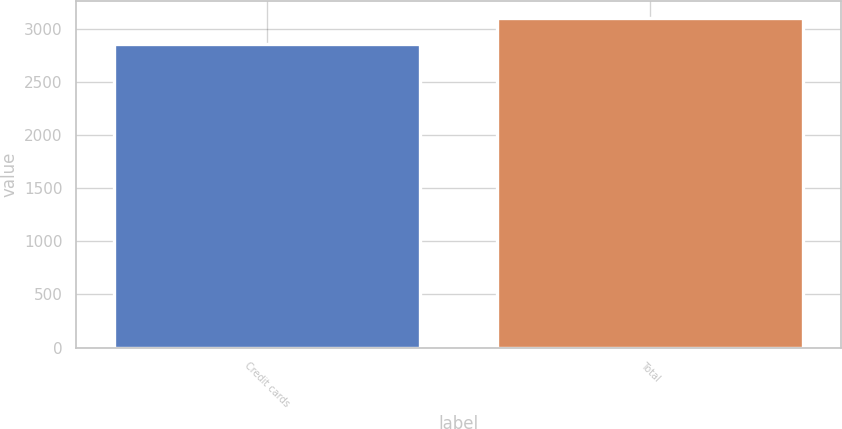Convert chart to OTSL. <chart><loc_0><loc_0><loc_500><loc_500><bar_chart><fcel>Credit cards<fcel>Total<nl><fcel>2850<fcel>3100<nl></chart> 